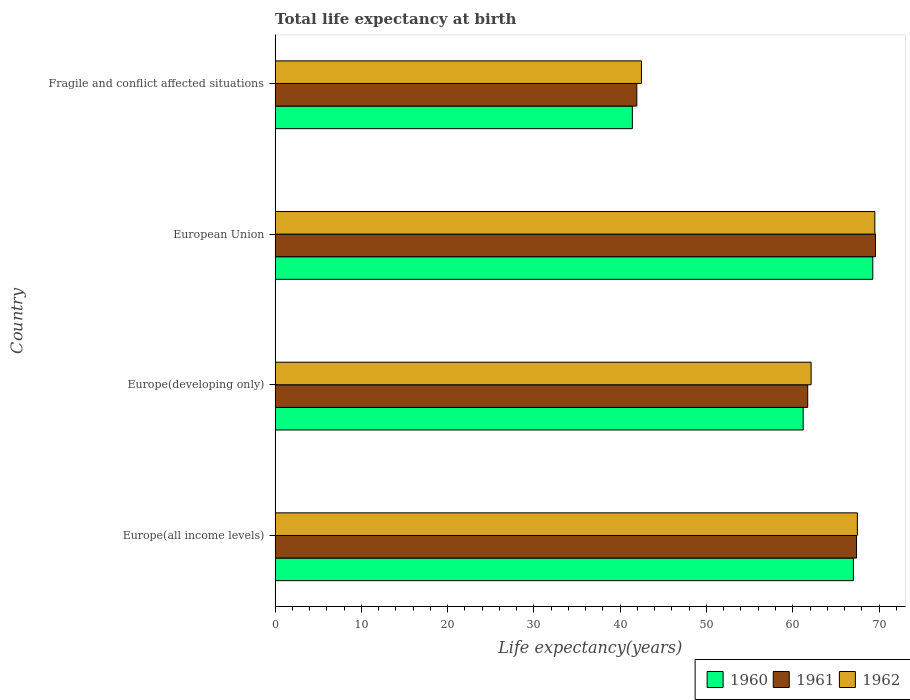How many groups of bars are there?
Keep it short and to the point. 4. Are the number of bars per tick equal to the number of legend labels?
Give a very brief answer. Yes. How many bars are there on the 2nd tick from the top?
Your response must be concise. 3. How many bars are there on the 2nd tick from the bottom?
Provide a short and direct response. 3. What is the life expectancy at birth in in 1962 in European Union?
Give a very brief answer. 69.51. Across all countries, what is the maximum life expectancy at birth in in 1962?
Your answer should be very brief. 69.51. Across all countries, what is the minimum life expectancy at birth in in 1962?
Your answer should be very brief. 42.47. In which country was the life expectancy at birth in in 1961 maximum?
Make the answer very short. European Union. In which country was the life expectancy at birth in in 1961 minimum?
Make the answer very short. Fragile and conflict affected situations. What is the total life expectancy at birth in in 1962 in the graph?
Offer a terse response. 241.6. What is the difference between the life expectancy at birth in in 1960 in Europe(developing only) and that in Fragile and conflict affected situations?
Keep it short and to the point. 19.8. What is the difference between the life expectancy at birth in in 1960 in Europe(developing only) and the life expectancy at birth in in 1961 in Fragile and conflict affected situations?
Provide a succinct answer. 19.28. What is the average life expectancy at birth in in 1962 per country?
Give a very brief answer. 60.4. What is the difference between the life expectancy at birth in in 1961 and life expectancy at birth in in 1962 in Europe(all income levels)?
Your answer should be compact. -0.09. In how many countries, is the life expectancy at birth in in 1962 greater than 40 years?
Offer a terse response. 4. What is the ratio of the life expectancy at birth in in 1961 in Europe(all income levels) to that in European Union?
Keep it short and to the point. 0.97. Is the difference between the life expectancy at birth in in 1961 in Europe(all income levels) and European Union greater than the difference between the life expectancy at birth in in 1962 in Europe(all income levels) and European Union?
Your answer should be compact. No. What is the difference between the highest and the second highest life expectancy at birth in in 1960?
Your response must be concise. 2.25. What is the difference between the highest and the lowest life expectancy at birth in in 1961?
Provide a succinct answer. 27.66. In how many countries, is the life expectancy at birth in in 1961 greater than the average life expectancy at birth in in 1961 taken over all countries?
Offer a terse response. 3. Is the sum of the life expectancy at birth in in 1962 in Europe(all income levels) and Europe(developing only) greater than the maximum life expectancy at birth in in 1960 across all countries?
Offer a very short reply. Yes. What does the 3rd bar from the top in Europe(all income levels) represents?
Provide a succinct answer. 1960. Is it the case that in every country, the sum of the life expectancy at birth in in 1961 and life expectancy at birth in in 1962 is greater than the life expectancy at birth in in 1960?
Offer a terse response. Yes. How many bars are there?
Your response must be concise. 12. Are all the bars in the graph horizontal?
Provide a succinct answer. Yes. How many countries are there in the graph?
Your answer should be very brief. 4. What is the difference between two consecutive major ticks on the X-axis?
Your answer should be compact. 10. Does the graph contain any zero values?
Offer a terse response. No. Where does the legend appear in the graph?
Your answer should be compact. Bottom right. How many legend labels are there?
Your answer should be compact. 3. How are the legend labels stacked?
Provide a succinct answer. Horizontal. What is the title of the graph?
Offer a very short reply. Total life expectancy at birth. Does "2009" appear as one of the legend labels in the graph?
Ensure brevity in your answer.  No. What is the label or title of the X-axis?
Your answer should be compact. Life expectancy(years). What is the label or title of the Y-axis?
Offer a very short reply. Country. What is the Life expectancy(years) in 1960 in Europe(all income levels)?
Ensure brevity in your answer.  67.03. What is the Life expectancy(years) of 1961 in Europe(all income levels)?
Give a very brief answer. 67.39. What is the Life expectancy(years) of 1962 in Europe(all income levels)?
Provide a short and direct response. 67.49. What is the Life expectancy(years) in 1960 in Europe(developing only)?
Keep it short and to the point. 61.21. What is the Life expectancy(years) in 1961 in Europe(developing only)?
Keep it short and to the point. 61.74. What is the Life expectancy(years) in 1962 in Europe(developing only)?
Ensure brevity in your answer.  62.13. What is the Life expectancy(years) in 1960 in European Union?
Offer a very short reply. 69.28. What is the Life expectancy(years) in 1961 in European Union?
Give a very brief answer. 69.59. What is the Life expectancy(years) of 1962 in European Union?
Keep it short and to the point. 69.51. What is the Life expectancy(years) of 1960 in Fragile and conflict affected situations?
Your answer should be very brief. 41.41. What is the Life expectancy(years) in 1961 in Fragile and conflict affected situations?
Offer a terse response. 41.93. What is the Life expectancy(years) of 1962 in Fragile and conflict affected situations?
Provide a succinct answer. 42.47. Across all countries, what is the maximum Life expectancy(years) of 1960?
Your answer should be compact. 69.28. Across all countries, what is the maximum Life expectancy(years) of 1961?
Give a very brief answer. 69.59. Across all countries, what is the maximum Life expectancy(years) of 1962?
Give a very brief answer. 69.51. Across all countries, what is the minimum Life expectancy(years) of 1960?
Offer a terse response. 41.41. Across all countries, what is the minimum Life expectancy(years) of 1961?
Ensure brevity in your answer.  41.93. Across all countries, what is the minimum Life expectancy(years) of 1962?
Your answer should be compact. 42.47. What is the total Life expectancy(years) of 1960 in the graph?
Make the answer very short. 238.93. What is the total Life expectancy(years) of 1961 in the graph?
Make the answer very short. 240.65. What is the total Life expectancy(years) of 1962 in the graph?
Give a very brief answer. 241.6. What is the difference between the Life expectancy(years) in 1960 in Europe(all income levels) and that in Europe(developing only)?
Your response must be concise. 5.82. What is the difference between the Life expectancy(years) of 1961 in Europe(all income levels) and that in Europe(developing only)?
Offer a terse response. 5.66. What is the difference between the Life expectancy(years) in 1962 in Europe(all income levels) and that in Europe(developing only)?
Your answer should be compact. 5.36. What is the difference between the Life expectancy(years) of 1960 in Europe(all income levels) and that in European Union?
Make the answer very short. -2.25. What is the difference between the Life expectancy(years) of 1961 in Europe(all income levels) and that in European Union?
Provide a succinct answer. -2.19. What is the difference between the Life expectancy(years) in 1962 in Europe(all income levels) and that in European Union?
Ensure brevity in your answer.  -2.03. What is the difference between the Life expectancy(years) in 1960 in Europe(all income levels) and that in Fragile and conflict affected situations?
Provide a succinct answer. 25.62. What is the difference between the Life expectancy(years) in 1961 in Europe(all income levels) and that in Fragile and conflict affected situations?
Offer a very short reply. 25.47. What is the difference between the Life expectancy(years) of 1962 in Europe(all income levels) and that in Fragile and conflict affected situations?
Give a very brief answer. 25.02. What is the difference between the Life expectancy(years) in 1960 in Europe(developing only) and that in European Union?
Offer a very short reply. -8.07. What is the difference between the Life expectancy(years) in 1961 in Europe(developing only) and that in European Union?
Your answer should be compact. -7.85. What is the difference between the Life expectancy(years) of 1962 in Europe(developing only) and that in European Union?
Provide a succinct answer. -7.39. What is the difference between the Life expectancy(years) of 1960 in Europe(developing only) and that in Fragile and conflict affected situations?
Provide a short and direct response. 19.8. What is the difference between the Life expectancy(years) of 1961 in Europe(developing only) and that in Fragile and conflict affected situations?
Provide a short and direct response. 19.81. What is the difference between the Life expectancy(years) in 1962 in Europe(developing only) and that in Fragile and conflict affected situations?
Give a very brief answer. 19.66. What is the difference between the Life expectancy(years) of 1960 in European Union and that in Fragile and conflict affected situations?
Your response must be concise. 27.87. What is the difference between the Life expectancy(years) of 1961 in European Union and that in Fragile and conflict affected situations?
Provide a short and direct response. 27.66. What is the difference between the Life expectancy(years) in 1962 in European Union and that in Fragile and conflict affected situations?
Your response must be concise. 27.05. What is the difference between the Life expectancy(years) of 1960 in Europe(all income levels) and the Life expectancy(years) of 1961 in Europe(developing only)?
Provide a succinct answer. 5.29. What is the difference between the Life expectancy(years) of 1960 in Europe(all income levels) and the Life expectancy(years) of 1962 in Europe(developing only)?
Give a very brief answer. 4.9. What is the difference between the Life expectancy(years) in 1961 in Europe(all income levels) and the Life expectancy(years) in 1962 in Europe(developing only)?
Your response must be concise. 5.27. What is the difference between the Life expectancy(years) of 1960 in Europe(all income levels) and the Life expectancy(years) of 1961 in European Union?
Give a very brief answer. -2.56. What is the difference between the Life expectancy(years) in 1960 in Europe(all income levels) and the Life expectancy(years) in 1962 in European Union?
Keep it short and to the point. -2.48. What is the difference between the Life expectancy(years) of 1961 in Europe(all income levels) and the Life expectancy(years) of 1962 in European Union?
Your answer should be very brief. -2.12. What is the difference between the Life expectancy(years) in 1960 in Europe(all income levels) and the Life expectancy(years) in 1961 in Fragile and conflict affected situations?
Offer a terse response. 25.1. What is the difference between the Life expectancy(years) of 1960 in Europe(all income levels) and the Life expectancy(years) of 1962 in Fragile and conflict affected situations?
Offer a very short reply. 24.56. What is the difference between the Life expectancy(years) in 1961 in Europe(all income levels) and the Life expectancy(years) in 1962 in Fragile and conflict affected situations?
Make the answer very short. 24.93. What is the difference between the Life expectancy(years) of 1960 in Europe(developing only) and the Life expectancy(years) of 1961 in European Union?
Your response must be concise. -8.38. What is the difference between the Life expectancy(years) of 1960 in Europe(developing only) and the Life expectancy(years) of 1962 in European Union?
Provide a short and direct response. -8.3. What is the difference between the Life expectancy(years) in 1961 in Europe(developing only) and the Life expectancy(years) in 1962 in European Union?
Your answer should be compact. -7.78. What is the difference between the Life expectancy(years) in 1960 in Europe(developing only) and the Life expectancy(years) in 1961 in Fragile and conflict affected situations?
Provide a succinct answer. 19.28. What is the difference between the Life expectancy(years) of 1960 in Europe(developing only) and the Life expectancy(years) of 1962 in Fragile and conflict affected situations?
Your response must be concise. 18.75. What is the difference between the Life expectancy(years) of 1961 in Europe(developing only) and the Life expectancy(years) of 1962 in Fragile and conflict affected situations?
Provide a succinct answer. 19.27. What is the difference between the Life expectancy(years) of 1960 in European Union and the Life expectancy(years) of 1961 in Fragile and conflict affected situations?
Provide a succinct answer. 27.35. What is the difference between the Life expectancy(years) in 1960 in European Union and the Life expectancy(years) in 1962 in Fragile and conflict affected situations?
Ensure brevity in your answer.  26.81. What is the difference between the Life expectancy(years) in 1961 in European Union and the Life expectancy(years) in 1962 in Fragile and conflict affected situations?
Provide a short and direct response. 27.12. What is the average Life expectancy(years) of 1960 per country?
Provide a succinct answer. 59.73. What is the average Life expectancy(years) in 1961 per country?
Ensure brevity in your answer.  60.16. What is the average Life expectancy(years) of 1962 per country?
Keep it short and to the point. 60.4. What is the difference between the Life expectancy(years) in 1960 and Life expectancy(years) in 1961 in Europe(all income levels)?
Your answer should be compact. -0.36. What is the difference between the Life expectancy(years) of 1960 and Life expectancy(years) of 1962 in Europe(all income levels)?
Keep it short and to the point. -0.46. What is the difference between the Life expectancy(years) of 1961 and Life expectancy(years) of 1962 in Europe(all income levels)?
Offer a very short reply. -0.09. What is the difference between the Life expectancy(years) of 1960 and Life expectancy(years) of 1961 in Europe(developing only)?
Provide a short and direct response. -0.53. What is the difference between the Life expectancy(years) in 1960 and Life expectancy(years) in 1962 in Europe(developing only)?
Your answer should be compact. -0.92. What is the difference between the Life expectancy(years) in 1961 and Life expectancy(years) in 1962 in Europe(developing only)?
Ensure brevity in your answer.  -0.39. What is the difference between the Life expectancy(years) in 1960 and Life expectancy(years) in 1961 in European Union?
Make the answer very short. -0.31. What is the difference between the Life expectancy(years) of 1960 and Life expectancy(years) of 1962 in European Union?
Provide a succinct answer. -0.23. What is the difference between the Life expectancy(years) in 1961 and Life expectancy(years) in 1962 in European Union?
Provide a short and direct response. 0.07. What is the difference between the Life expectancy(years) in 1960 and Life expectancy(years) in 1961 in Fragile and conflict affected situations?
Your answer should be very brief. -0.52. What is the difference between the Life expectancy(years) of 1960 and Life expectancy(years) of 1962 in Fragile and conflict affected situations?
Your answer should be very brief. -1.05. What is the difference between the Life expectancy(years) of 1961 and Life expectancy(years) of 1962 in Fragile and conflict affected situations?
Offer a terse response. -0.54. What is the ratio of the Life expectancy(years) in 1960 in Europe(all income levels) to that in Europe(developing only)?
Make the answer very short. 1.1. What is the ratio of the Life expectancy(years) in 1961 in Europe(all income levels) to that in Europe(developing only)?
Offer a terse response. 1.09. What is the ratio of the Life expectancy(years) of 1962 in Europe(all income levels) to that in Europe(developing only)?
Your answer should be very brief. 1.09. What is the ratio of the Life expectancy(years) of 1960 in Europe(all income levels) to that in European Union?
Provide a succinct answer. 0.97. What is the ratio of the Life expectancy(years) in 1961 in Europe(all income levels) to that in European Union?
Keep it short and to the point. 0.97. What is the ratio of the Life expectancy(years) in 1962 in Europe(all income levels) to that in European Union?
Offer a very short reply. 0.97. What is the ratio of the Life expectancy(years) in 1960 in Europe(all income levels) to that in Fragile and conflict affected situations?
Your answer should be very brief. 1.62. What is the ratio of the Life expectancy(years) of 1961 in Europe(all income levels) to that in Fragile and conflict affected situations?
Your answer should be very brief. 1.61. What is the ratio of the Life expectancy(years) in 1962 in Europe(all income levels) to that in Fragile and conflict affected situations?
Your response must be concise. 1.59. What is the ratio of the Life expectancy(years) in 1960 in Europe(developing only) to that in European Union?
Ensure brevity in your answer.  0.88. What is the ratio of the Life expectancy(years) of 1961 in Europe(developing only) to that in European Union?
Provide a succinct answer. 0.89. What is the ratio of the Life expectancy(years) of 1962 in Europe(developing only) to that in European Union?
Ensure brevity in your answer.  0.89. What is the ratio of the Life expectancy(years) of 1960 in Europe(developing only) to that in Fragile and conflict affected situations?
Your answer should be very brief. 1.48. What is the ratio of the Life expectancy(years) of 1961 in Europe(developing only) to that in Fragile and conflict affected situations?
Your answer should be compact. 1.47. What is the ratio of the Life expectancy(years) of 1962 in Europe(developing only) to that in Fragile and conflict affected situations?
Offer a very short reply. 1.46. What is the ratio of the Life expectancy(years) in 1960 in European Union to that in Fragile and conflict affected situations?
Offer a terse response. 1.67. What is the ratio of the Life expectancy(years) of 1961 in European Union to that in Fragile and conflict affected situations?
Your response must be concise. 1.66. What is the ratio of the Life expectancy(years) of 1962 in European Union to that in Fragile and conflict affected situations?
Offer a very short reply. 1.64. What is the difference between the highest and the second highest Life expectancy(years) in 1960?
Provide a short and direct response. 2.25. What is the difference between the highest and the second highest Life expectancy(years) in 1961?
Your answer should be compact. 2.19. What is the difference between the highest and the second highest Life expectancy(years) of 1962?
Your response must be concise. 2.03. What is the difference between the highest and the lowest Life expectancy(years) in 1960?
Your answer should be very brief. 27.87. What is the difference between the highest and the lowest Life expectancy(years) of 1961?
Make the answer very short. 27.66. What is the difference between the highest and the lowest Life expectancy(years) in 1962?
Your answer should be compact. 27.05. 